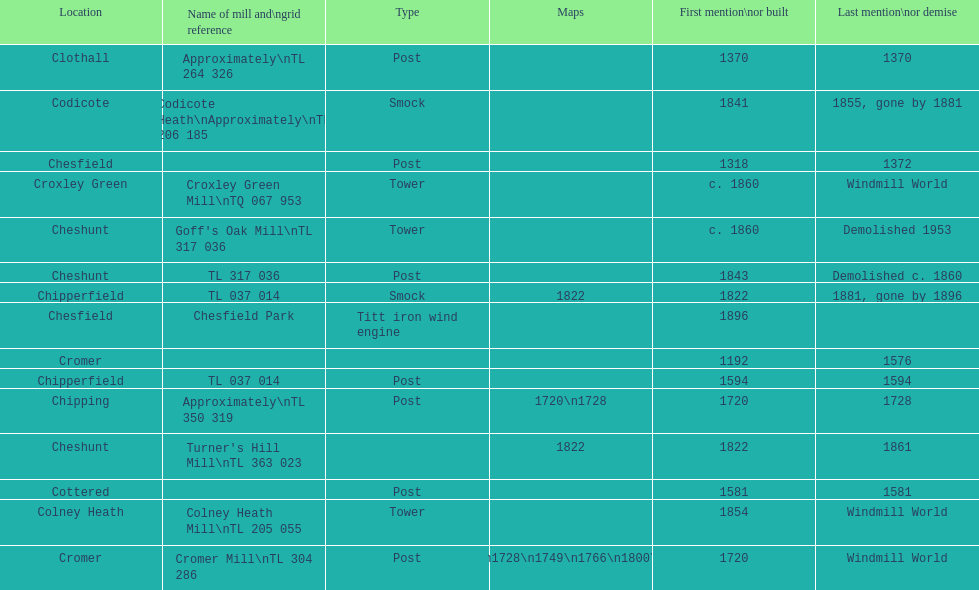How many mills were built or first mentioned after 1800? 8. 